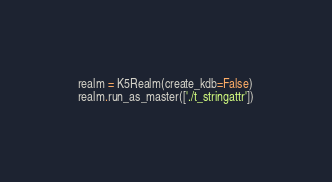Convert code to text. <code><loc_0><loc_0><loc_500><loc_500><_Python_>realm = K5Realm(create_kdb=False)
realm.run_as_master(['./t_stringattr'])</code> 